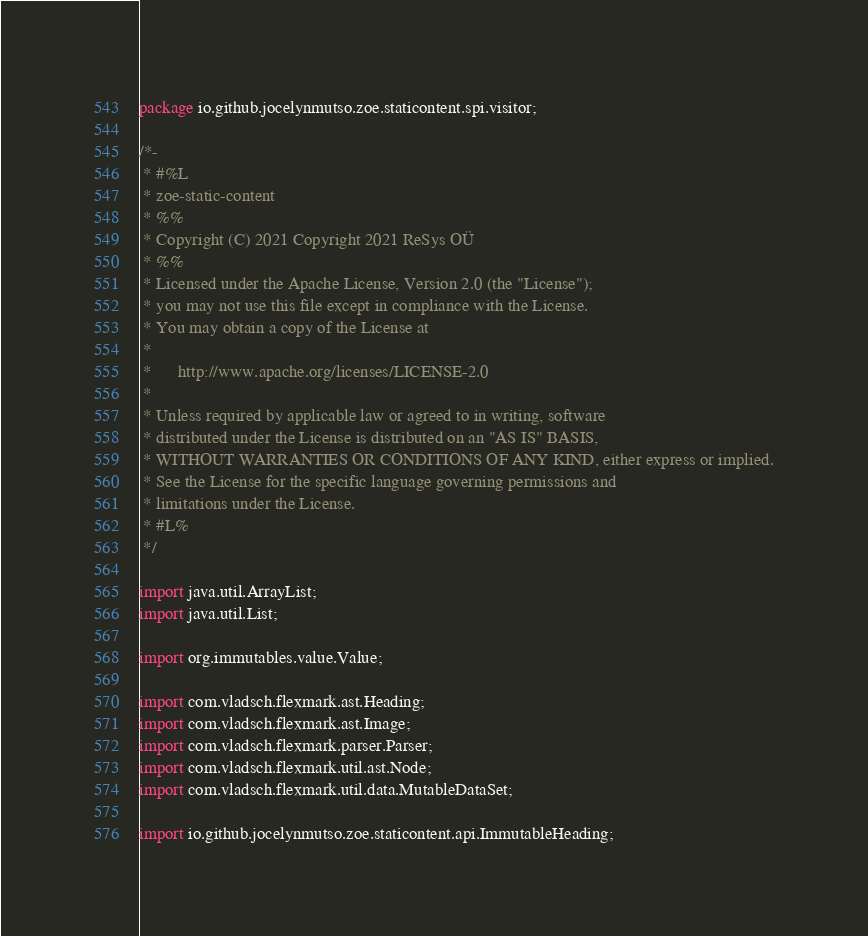Convert code to text. <code><loc_0><loc_0><loc_500><loc_500><_Java_>package io.github.jocelynmutso.zoe.staticontent.spi.visitor;

/*-
 * #%L
 * zoe-static-content
 * %%
 * Copyright (C) 2021 Copyright 2021 ReSys OÜ
 * %%
 * Licensed under the Apache License, Version 2.0 (the "License");
 * you may not use this file except in compliance with the License.
 * You may obtain a copy of the License at
 * 
 *      http://www.apache.org/licenses/LICENSE-2.0
 * 
 * Unless required by applicable law or agreed to in writing, software
 * distributed under the License is distributed on an "AS IS" BASIS,
 * WITHOUT WARRANTIES OR CONDITIONS OF ANY KIND, either express or implied.
 * See the License for the specific language governing permissions and
 * limitations under the License.
 * #L%
 */

import java.util.ArrayList;
import java.util.List;

import org.immutables.value.Value;

import com.vladsch.flexmark.ast.Heading;
import com.vladsch.flexmark.ast.Image;
import com.vladsch.flexmark.parser.Parser;
import com.vladsch.flexmark.util.ast.Node;
import com.vladsch.flexmark.util.data.MutableDataSet;

import io.github.jocelynmutso.zoe.staticontent.api.ImmutableHeading;</code> 